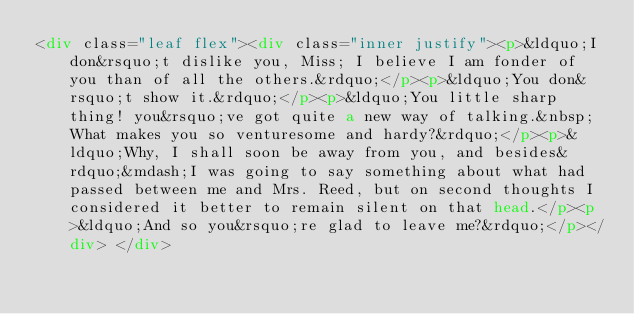<code> <loc_0><loc_0><loc_500><loc_500><_HTML_><div class="leaf flex"><div class="inner justify"><p>&ldquo;I don&rsquo;t dislike you, Miss; I believe I am fonder of you than of all the others.&rdquo;</p><p>&ldquo;You don&rsquo;t show it.&rdquo;</p><p>&ldquo;You little sharp thing! you&rsquo;ve got quite a new way of talking.&nbsp; What makes you so venturesome and hardy?&rdquo;</p><p>&ldquo;Why, I shall soon be away from you, and besides&rdquo;&mdash;I was going to say something about what had passed between me and Mrs. Reed, but on second thoughts I considered it better to remain silent on that head.</p><p>&ldquo;And so you&rsquo;re glad to leave me?&rdquo;</p></div> </div></code> 